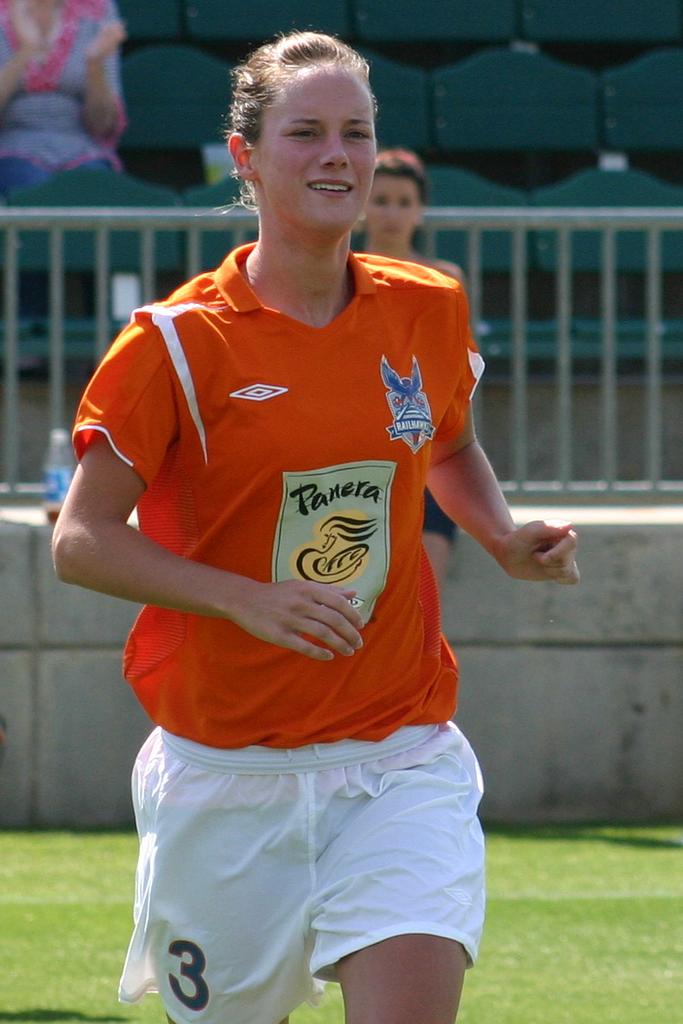What number is she?
Provide a succinct answer. 3. What logo is on the shirt?
Give a very brief answer. Panera. 